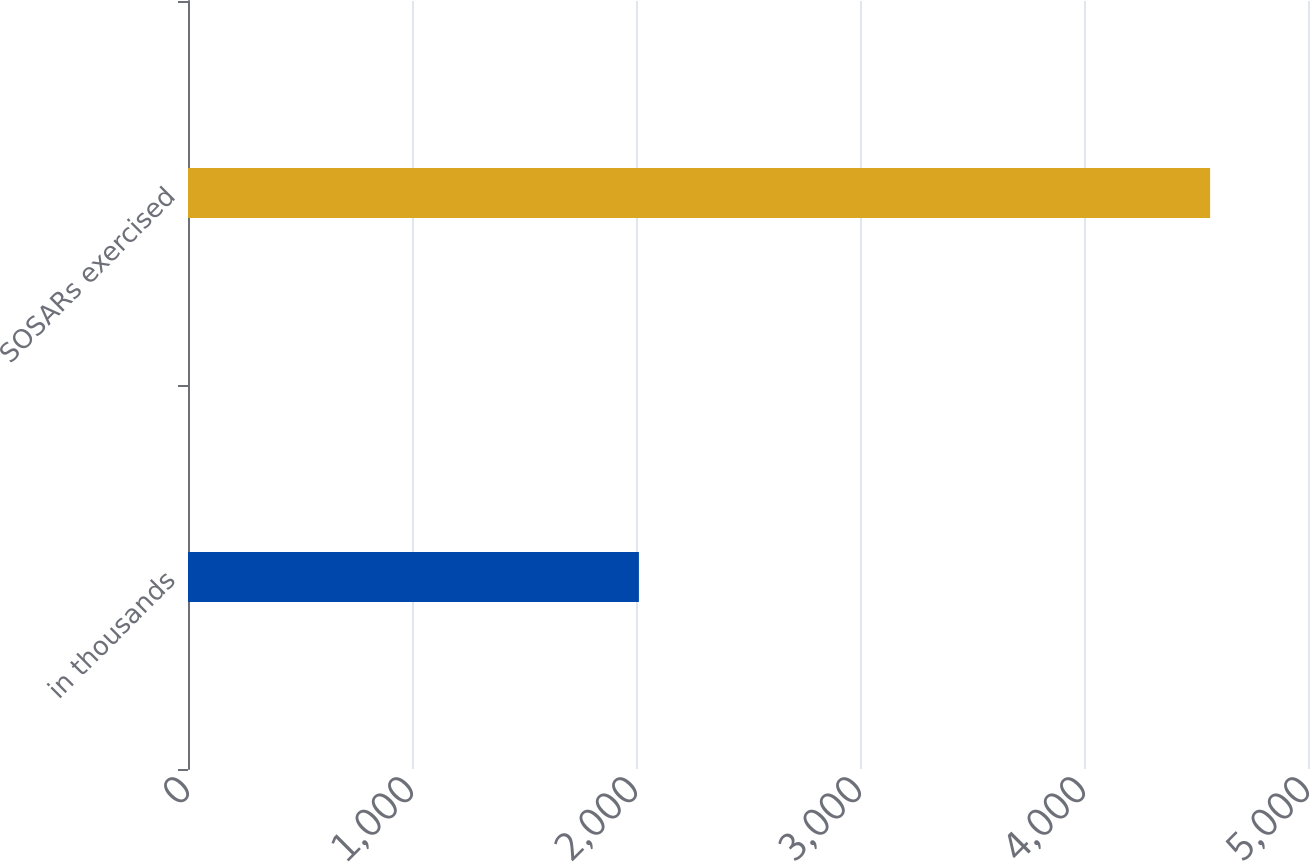Convert chart. <chart><loc_0><loc_0><loc_500><loc_500><bar_chart><fcel>in thousands<fcel>SOSARs exercised<nl><fcel>2013<fcel>4563<nl></chart> 